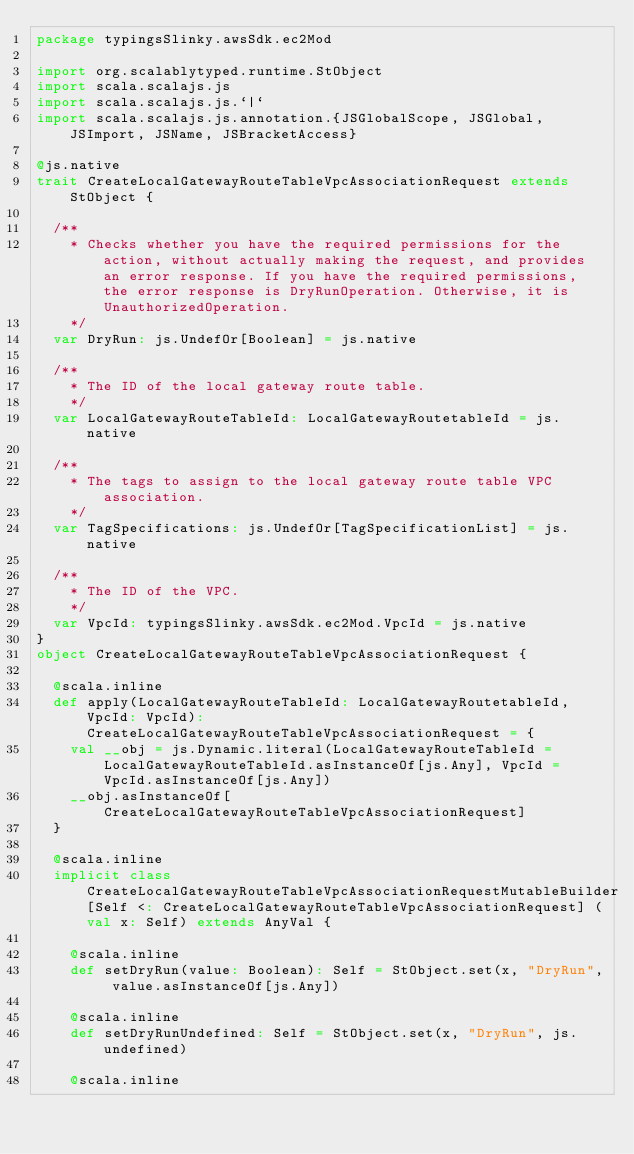<code> <loc_0><loc_0><loc_500><loc_500><_Scala_>package typingsSlinky.awsSdk.ec2Mod

import org.scalablytyped.runtime.StObject
import scala.scalajs.js
import scala.scalajs.js.`|`
import scala.scalajs.js.annotation.{JSGlobalScope, JSGlobal, JSImport, JSName, JSBracketAccess}

@js.native
trait CreateLocalGatewayRouteTableVpcAssociationRequest extends StObject {
  
  /**
    * Checks whether you have the required permissions for the action, without actually making the request, and provides an error response. If you have the required permissions, the error response is DryRunOperation. Otherwise, it is UnauthorizedOperation.
    */
  var DryRun: js.UndefOr[Boolean] = js.native
  
  /**
    * The ID of the local gateway route table.
    */
  var LocalGatewayRouteTableId: LocalGatewayRoutetableId = js.native
  
  /**
    * The tags to assign to the local gateway route table VPC association.
    */
  var TagSpecifications: js.UndefOr[TagSpecificationList] = js.native
  
  /**
    * The ID of the VPC.
    */
  var VpcId: typingsSlinky.awsSdk.ec2Mod.VpcId = js.native
}
object CreateLocalGatewayRouteTableVpcAssociationRequest {
  
  @scala.inline
  def apply(LocalGatewayRouteTableId: LocalGatewayRoutetableId, VpcId: VpcId): CreateLocalGatewayRouteTableVpcAssociationRequest = {
    val __obj = js.Dynamic.literal(LocalGatewayRouteTableId = LocalGatewayRouteTableId.asInstanceOf[js.Any], VpcId = VpcId.asInstanceOf[js.Any])
    __obj.asInstanceOf[CreateLocalGatewayRouteTableVpcAssociationRequest]
  }
  
  @scala.inline
  implicit class CreateLocalGatewayRouteTableVpcAssociationRequestMutableBuilder[Self <: CreateLocalGatewayRouteTableVpcAssociationRequest] (val x: Self) extends AnyVal {
    
    @scala.inline
    def setDryRun(value: Boolean): Self = StObject.set(x, "DryRun", value.asInstanceOf[js.Any])
    
    @scala.inline
    def setDryRunUndefined: Self = StObject.set(x, "DryRun", js.undefined)
    
    @scala.inline</code> 